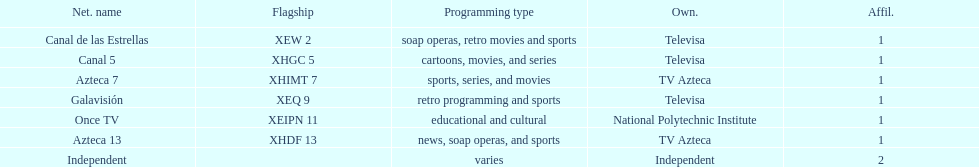What is the only network owned by national polytechnic institute? Once TV. 